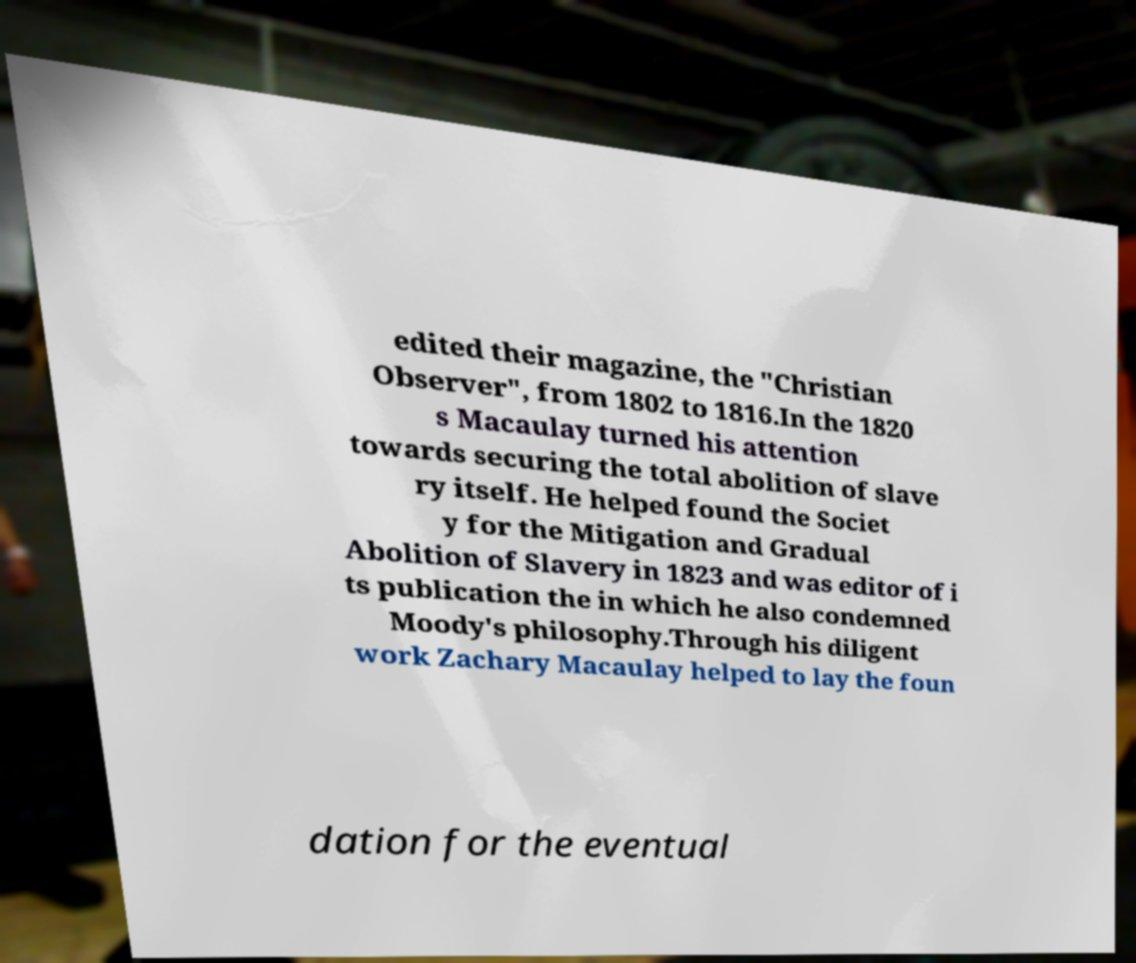For documentation purposes, I need the text within this image transcribed. Could you provide that? edited their magazine, the "Christian Observer", from 1802 to 1816.In the 1820 s Macaulay turned his attention towards securing the total abolition of slave ry itself. He helped found the Societ y for the Mitigation and Gradual Abolition of Slavery in 1823 and was editor of i ts publication the in which he also condemned Moody's philosophy.Through his diligent work Zachary Macaulay helped to lay the foun dation for the eventual 